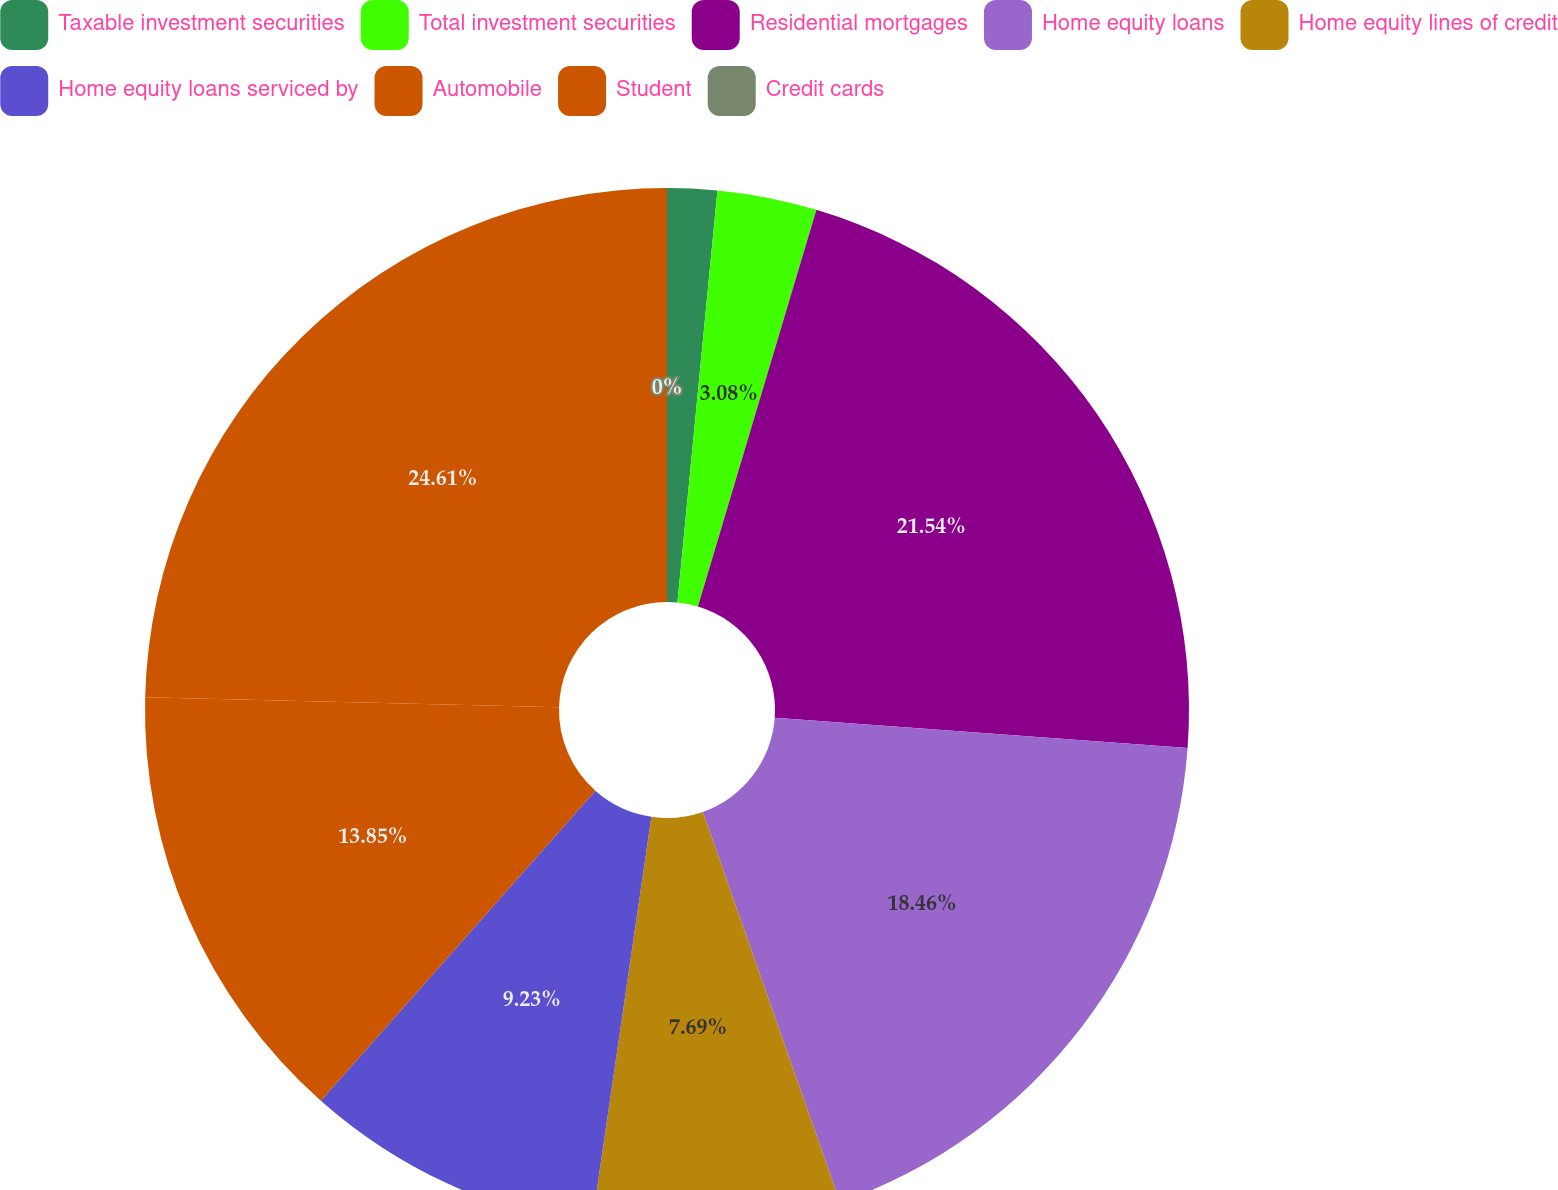<chart> <loc_0><loc_0><loc_500><loc_500><pie_chart><fcel>Taxable investment securities<fcel>Total investment securities<fcel>Residential mortgages<fcel>Home equity loans<fcel>Home equity lines of credit<fcel>Home equity loans serviced by<fcel>Automobile<fcel>Student<fcel>Credit cards<nl><fcel>1.54%<fcel>3.08%<fcel>21.54%<fcel>18.46%<fcel>7.69%<fcel>9.23%<fcel>13.85%<fcel>24.61%<fcel>0.0%<nl></chart> 